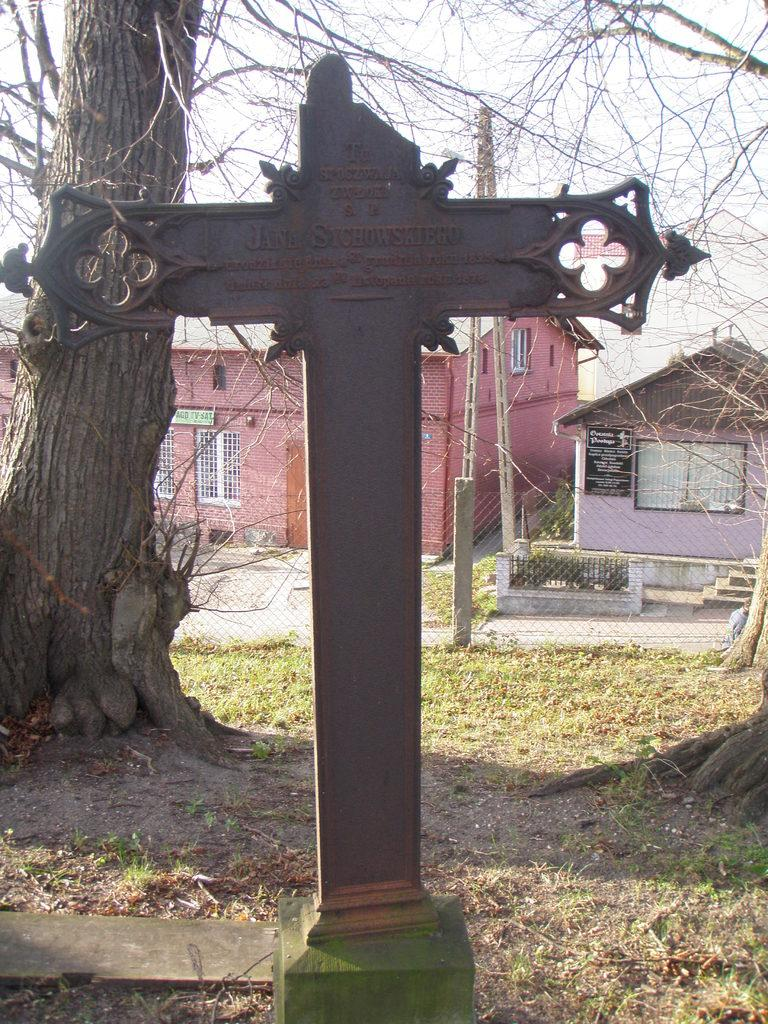What is the main subject of the image? The main subject of the image is a cross with written letters. What can be seen on the backside of the cross? There is a bark of a tree visible on the backside of the cross. What type of structures can be seen in the image? There are houses with roofs and windows in the image. What type of barrier is present in the image? There is a fence in the image. What type of vegetation is present in the image? Dried branches are present in the image. What is visible in the sky in the image? The sky is visible in the image. Can you see a chain of islands in the ocean in the image? There is no ocean or chain of islands present in the image. 